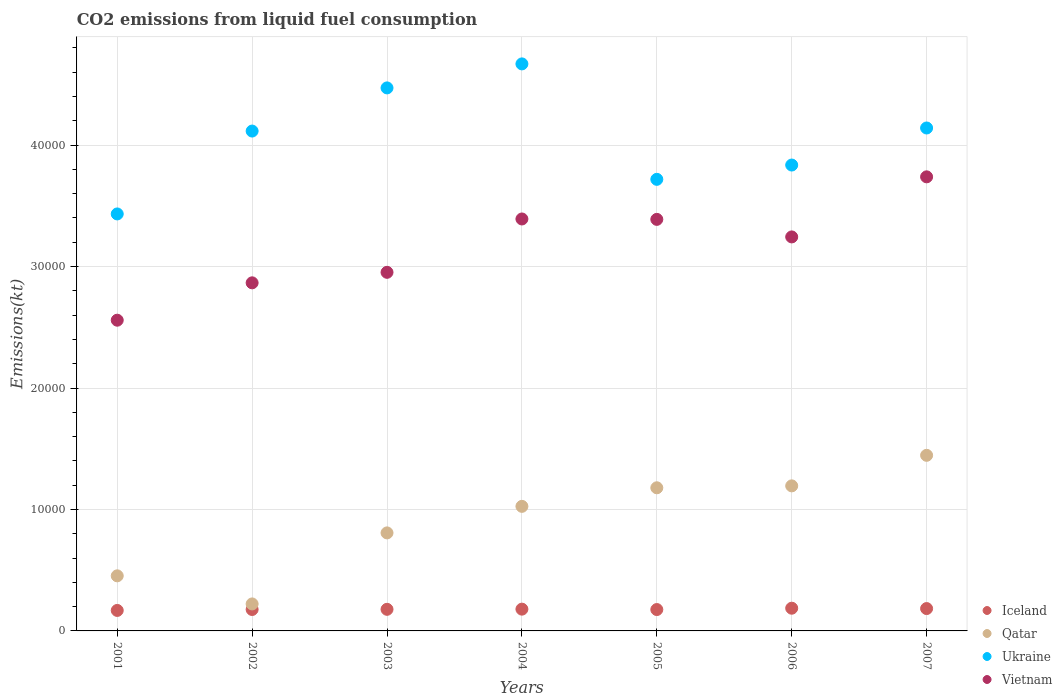How many different coloured dotlines are there?
Your response must be concise. 4. Is the number of dotlines equal to the number of legend labels?
Your answer should be compact. Yes. What is the amount of CO2 emitted in Vietnam in 2003?
Make the answer very short. 2.95e+04. Across all years, what is the maximum amount of CO2 emitted in Vietnam?
Give a very brief answer. 3.74e+04. Across all years, what is the minimum amount of CO2 emitted in Qatar?
Keep it short and to the point. 2222.2. In which year was the amount of CO2 emitted in Qatar maximum?
Your answer should be compact. 2007. What is the total amount of CO2 emitted in Qatar in the graph?
Provide a short and direct response. 6.33e+04. What is the difference between the amount of CO2 emitted in Ukraine in 2001 and that in 2002?
Make the answer very short. -6824.29. What is the difference between the amount of CO2 emitted in Vietnam in 2003 and the amount of CO2 emitted in Qatar in 2001?
Offer a terse response. 2.50e+04. What is the average amount of CO2 emitted in Ukraine per year?
Offer a terse response. 4.05e+04. In the year 2004, what is the difference between the amount of CO2 emitted in Ukraine and amount of CO2 emitted in Vietnam?
Offer a terse response. 1.28e+04. In how many years, is the amount of CO2 emitted in Vietnam greater than 46000 kt?
Your response must be concise. 0. What is the ratio of the amount of CO2 emitted in Ukraine in 2003 to that in 2005?
Make the answer very short. 1.2. Is the amount of CO2 emitted in Iceland in 2003 less than that in 2005?
Keep it short and to the point. No. What is the difference between the highest and the second highest amount of CO2 emitted in Ukraine?
Give a very brief answer. 1976.51. What is the difference between the highest and the lowest amount of CO2 emitted in Qatar?
Offer a terse response. 1.22e+04. Is it the case that in every year, the sum of the amount of CO2 emitted in Ukraine and amount of CO2 emitted in Iceland  is greater than the amount of CO2 emitted in Vietnam?
Keep it short and to the point. Yes. Is the amount of CO2 emitted in Vietnam strictly greater than the amount of CO2 emitted in Qatar over the years?
Your response must be concise. Yes. Are the values on the major ticks of Y-axis written in scientific E-notation?
Give a very brief answer. No. Does the graph contain any zero values?
Keep it short and to the point. No. Where does the legend appear in the graph?
Your response must be concise. Bottom right. What is the title of the graph?
Make the answer very short. CO2 emissions from liquid fuel consumption. Does "Mozambique" appear as one of the legend labels in the graph?
Offer a terse response. No. What is the label or title of the Y-axis?
Your answer should be very brief. Emissions(kt). What is the Emissions(kt) in Iceland in 2001?
Give a very brief answer. 1686.82. What is the Emissions(kt) in Qatar in 2001?
Offer a terse response. 4536.08. What is the Emissions(kt) of Ukraine in 2001?
Your answer should be compact. 3.43e+04. What is the Emissions(kt) of Vietnam in 2001?
Provide a short and direct response. 2.56e+04. What is the Emissions(kt) in Iceland in 2002?
Ensure brevity in your answer.  1763.83. What is the Emissions(kt) in Qatar in 2002?
Your answer should be compact. 2222.2. What is the Emissions(kt) in Ukraine in 2002?
Keep it short and to the point. 4.12e+04. What is the Emissions(kt) of Vietnam in 2002?
Offer a terse response. 2.87e+04. What is the Emissions(kt) of Iceland in 2003?
Your answer should be very brief. 1778.49. What is the Emissions(kt) in Qatar in 2003?
Your response must be concise. 8071.07. What is the Emissions(kt) of Ukraine in 2003?
Your response must be concise. 4.47e+04. What is the Emissions(kt) of Vietnam in 2003?
Ensure brevity in your answer.  2.95e+04. What is the Emissions(kt) of Iceland in 2004?
Your answer should be compact. 1793.16. What is the Emissions(kt) in Qatar in 2004?
Keep it short and to the point. 1.03e+04. What is the Emissions(kt) in Ukraine in 2004?
Provide a short and direct response. 4.67e+04. What is the Emissions(kt) of Vietnam in 2004?
Make the answer very short. 3.39e+04. What is the Emissions(kt) in Iceland in 2005?
Ensure brevity in your answer.  1760.16. What is the Emissions(kt) of Qatar in 2005?
Provide a short and direct response. 1.18e+04. What is the Emissions(kt) in Ukraine in 2005?
Give a very brief answer. 3.72e+04. What is the Emissions(kt) in Vietnam in 2005?
Give a very brief answer. 3.39e+04. What is the Emissions(kt) of Iceland in 2006?
Your answer should be very brief. 1870.17. What is the Emissions(kt) of Qatar in 2006?
Offer a very short reply. 1.19e+04. What is the Emissions(kt) of Ukraine in 2006?
Provide a short and direct response. 3.84e+04. What is the Emissions(kt) in Vietnam in 2006?
Provide a succinct answer. 3.24e+04. What is the Emissions(kt) of Iceland in 2007?
Keep it short and to the point. 1840.83. What is the Emissions(kt) in Qatar in 2007?
Keep it short and to the point. 1.45e+04. What is the Emissions(kt) in Ukraine in 2007?
Offer a very short reply. 4.14e+04. What is the Emissions(kt) in Vietnam in 2007?
Make the answer very short. 3.74e+04. Across all years, what is the maximum Emissions(kt) of Iceland?
Ensure brevity in your answer.  1870.17. Across all years, what is the maximum Emissions(kt) of Qatar?
Provide a succinct answer. 1.45e+04. Across all years, what is the maximum Emissions(kt) of Ukraine?
Offer a very short reply. 4.67e+04. Across all years, what is the maximum Emissions(kt) in Vietnam?
Your response must be concise. 3.74e+04. Across all years, what is the minimum Emissions(kt) in Iceland?
Keep it short and to the point. 1686.82. Across all years, what is the minimum Emissions(kt) in Qatar?
Your response must be concise. 2222.2. Across all years, what is the minimum Emissions(kt) in Ukraine?
Your response must be concise. 3.43e+04. Across all years, what is the minimum Emissions(kt) of Vietnam?
Provide a short and direct response. 2.56e+04. What is the total Emissions(kt) of Iceland in the graph?
Your answer should be compact. 1.25e+04. What is the total Emissions(kt) in Qatar in the graph?
Keep it short and to the point. 6.33e+04. What is the total Emissions(kt) of Ukraine in the graph?
Your answer should be very brief. 2.84e+05. What is the total Emissions(kt) of Vietnam in the graph?
Offer a terse response. 2.21e+05. What is the difference between the Emissions(kt) in Iceland in 2001 and that in 2002?
Provide a succinct answer. -77.01. What is the difference between the Emissions(kt) of Qatar in 2001 and that in 2002?
Keep it short and to the point. 2313.88. What is the difference between the Emissions(kt) of Ukraine in 2001 and that in 2002?
Offer a terse response. -6824.29. What is the difference between the Emissions(kt) in Vietnam in 2001 and that in 2002?
Your response must be concise. -3076.61. What is the difference between the Emissions(kt) in Iceland in 2001 and that in 2003?
Ensure brevity in your answer.  -91.67. What is the difference between the Emissions(kt) in Qatar in 2001 and that in 2003?
Offer a terse response. -3534.99. What is the difference between the Emissions(kt) of Ukraine in 2001 and that in 2003?
Offer a terse response. -1.04e+04. What is the difference between the Emissions(kt) of Vietnam in 2001 and that in 2003?
Keep it short and to the point. -3942.03. What is the difference between the Emissions(kt) in Iceland in 2001 and that in 2004?
Offer a terse response. -106.34. What is the difference between the Emissions(kt) in Qatar in 2001 and that in 2004?
Give a very brief answer. -5720.52. What is the difference between the Emissions(kt) in Ukraine in 2001 and that in 2004?
Provide a short and direct response. -1.24e+04. What is the difference between the Emissions(kt) of Vietnam in 2001 and that in 2004?
Keep it short and to the point. -8335.09. What is the difference between the Emissions(kt) of Iceland in 2001 and that in 2005?
Offer a terse response. -73.34. What is the difference between the Emissions(kt) in Qatar in 2001 and that in 2005?
Ensure brevity in your answer.  -7249.66. What is the difference between the Emissions(kt) in Ukraine in 2001 and that in 2005?
Your answer should be compact. -2849.26. What is the difference between the Emissions(kt) of Vietnam in 2001 and that in 2005?
Keep it short and to the point. -8302.09. What is the difference between the Emissions(kt) in Iceland in 2001 and that in 2006?
Keep it short and to the point. -183.35. What is the difference between the Emissions(kt) of Qatar in 2001 and that in 2006?
Your answer should be very brief. -7407.34. What is the difference between the Emissions(kt) in Ukraine in 2001 and that in 2006?
Keep it short and to the point. -4026.37. What is the difference between the Emissions(kt) of Vietnam in 2001 and that in 2006?
Ensure brevity in your answer.  -6857.29. What is the difference between the Emissions(kt) of Iceland in 2001 and that in 2007?
Provide a short and direct response. -154.01. What is the difference between the Emissions(kt) of Qatar in 2001 and that in 2007?
Give a very brief answer. -9922.9. What is the difference between the Emissions(kt) in Ukraine in 2001 and that in 2007?
Your response must be concise. -7077.31. What is the difference between the Emissions(kt) in Vietnam in 2001 and that in 2007?
Provide a succinct answer. -1.18e+04. What is the difference between the Emissions(kt) of Iceland in 2002 and that in 2003?
Provide a short and direct response. -14.67. What is the difference between the Emissions(kt) in Qatar in 2002 and that in 2003?
Offer a terse response. -5848.86. What is the difference between the Emissions(kt) of Ukraine in 2002 and that in 2003?
Provide a succinct answer. -3553.32. What is the difference between the Emissions(kt) in Vietnam in 2002 and that in 2003?
Your answer should be compact. -865.41. What is the difference between the Emissions(kt) in Iceland in 2002 and that in 2004?
Your answer should be very brief. -29.34. What is the difference between the Emissions(kt) of Qatar in 2002 and that in 2004?
Make the answer very short. -8034.4. What is the difference between the Emissions(kt) in Ukraine in 2002 and that in 2004?
Your response must be concise. -5529.84. What is the difference between the Emissions(kt) of Vietnam in 2002 and that in 2004?
Provide a short and direct response. -5258.48. What is the difference between the Emissions(kt) of Iceland in 2002 and that in 2005?
Your response must be concise. 3.67. What is the difference between the Emissions(kt) of Qatar in 2002 and that in 2005?
Provide a short and direct response. -9563.54. What is the difference between the Emissions(kt) of Ukraine in 2002 and that in 2005?
Your answer should be compact. 3975.03. What is the difference between the Emissions(kt) in Vietnam in 2002 and that in 2005?
Your answer should be very brief. -5225.48. What is the difference between the Emissions(kt) in Iceland in 2002 and that in 2006?
Your answer should be compact. -106.34. What is the difference between the Emissions(kt) in Qatar in 2002 and that in 2006?
Provide a short and direct response. -9721.22. What is the difference between the Emissions(kt) in Ukraine in 2002 and that in 2006?
Offer a very short reply. 2797.92. What is the difference between the Emissions(kt) of Vietnam in 2002 and that in 2006?
Give a very brief answer. -3780.68. What is the difference between the Emissions(kt) of Iceland in 2002 and that in 2007?
Give a very brief answer. -77.01. What is the difference between the Emissions(kt) in Qatar in 2002 and that in 2007?
Ensure brevity in your answer.  -1.22e+04. What is the difference between the Emissions(kt) in Ukraine in 2002 and that in 2007?
Your answer should be very brief. -253.02. What is the difference between the Emissions(kt) of Vietnam in 2002 and that in 2007?
Keep it short and to the point. -8727.46. What is the difference between the Emissions(kt) in Iceland in 2003 and that in 2004?
Provide a succinct answer. -14.67. What is the difference between the Emissions(kt) of Qatar in 2003 and that in 2004?
Provide a short and direct response. -2185.53. What is the difference between the Emissions(kt) of Ukraine in 2003 and that in 2004?
Offer a terse response. -1976.51. What is the difference between the Emissions(kt) of Vietnam in 2003 and that in 2004?
Ensure brevity in your answer.  -4393.07. What is the difference between the Emissions(kt) of Iceland in 2003 and that in 2005?
Give a very brief answer. 18.34. What is the difference between the Emissions(kt) of Qatar in 2003 and that in 2005?
Ensure brevity in your answer.  -3714.67. What is the difference between the Emissions(kt) of Ukraine in 2003 and that in 2005?
Your answer should be very brief. 7528.35. What is the difference between the Emissions(kt) in Vietnam in 2003 and that in 2005?
Offer a terse response. -4360.06. What is the difference between the Emissions(kt) of Iceland in 2003 and that in 2006?
Offer a terse response. -91.67. What is the difference between the Emissions(kt) in Qatar in 2003 and that in 2006?
Keep it short and to the point. -3872.35. What is the difference between the Emissions(kt) of Ukraine in 2003 and that in 2006?
Offer a very short reply. 6351.24. What is the difference between the Emissions(kt) of Vietnam in 2003 and that in 2006?
Provide a short and direct response. -2915.26. What is the difference between the Emissions(kt) in Iceland in 2003 and that in 2007?
Your answer should be compact. -62.34. What is the difference between the Emissions(kt) in Qatar in 2003 and that in 2007?
Your response must be concise. -6387.91. What is the difference between the Emissions(kt) of Ukraine in 2003 and that in 2007?
Give a very brief answer. 3300.3. What is the difference between the Emissions(kt) in Vietnam in 2003 and that in 2007?
Offer a very short reply. -7862.05. What is the difference between the Emissions(kt) of Iceland in 2004 and that in 2005?
Ensure brevity in your answer.  33. What is the difference between the Emissions(kt) in Qatar in 2004 and that in 2005?
Your answer should be compact. -1529.14. What is the difference between the Emissions(kt) of Ukraine in 2004 and that in 2005?
Give a very brief answer. 9504.86. What is the difference between the Emissions(kt) in Vietnam in 2004 and that in 2005?
Offer a very short reply. 33. What is the difference between the Emissions(kt) of Iceland in 2004 and that in 2006?
Your answer should be very brief. -77.01. What is the difference between the Emissions(kt) in Qatar in 2004 and that in 2006?
Make the answer very short. -1686.82. What is the difference between the Emissions(kt) in Ukraine in 2004 and that in 2006?
Ensure brevity in your answer.  8327.76. What is the difference between the Emissions(kt) in Vietnam in 2004 and that in 2006?
Ensure brevity in your answer.  1477.8. What is the difference between the Emissions(kt) of Iceland in 2004 and that in 2007?
Make the answer very short. -47.67. What is the difference between the Emissions(kt) in Qatar in 2004 and that in 2007?
Keep it short and to the point. -4202.38. What is the difference between the Emissions(kt) in Ukraine in 2004 and that in 2007?
Provide a short and direct response. 5276.81. What is the difference between the Emissions(kt) of Vietnam in 2004 and that in 2007?
Make the answer very short. -3468.98. What is the difference between the Emissions(kt) of Iceland in 2005 and that in 2006?
Your response must be concise. -110.01. What is the difference between the Emissions(kt) in Qatar in 2005 and that in 2006?
Ensure brevity in your answer.  -157.68. What is the difference between the Emissions(kt) in Ukraine in 2005 and that in 2006?
Make the answer very short. -1177.11. What is the difference between the Emissions(kt) in Vietnam in 2005 and that in 2006?
Ensure brevity in your answer.  1444.8. What is the difference between the Emissions(kt) of Iceland in 2005 and that in 2007?
Make the answer very short. -80.67. What is the difference between the Emissions(kt) of Qatar in 2005 and that in 2007?
Ensure brevity in your answer.  -2673.24. What is the difference between the Emissions(kt) of Ukraine in 2005 and that in 2007?
Provide a succinct answer. -4228.05. What is the difference between the Emissions(kt) in Vietnam in 2005 and that in 2007?
Keep it short and to the point. -3501.99. What is the difference between the Emissions(kt) in Iceland in 2006 and that in 2007?
Offer a terse response. 29.34. What is the difference between the Emissions(kt) in Qatar in 2006 and that in 2007?
Give a very brief answer. -2515.56. What is the difference between the Emissions(kt) in Ukraine in 2006 and that in 2007?
Your response must be concise. -3050.94. What is the difference between the Emissions(kt) in Vietnam in 2006 and that in 2007?
Keep it short and to the point. -4946.78. What is the difference between the Emissions(kt) of Iceland in 2001 and the Emissions(kt) of Qatar in 2002?
Give a very brief answer. -535.38. What is the difference between the Emissions(kt) in Iceland in 2001 and the Emissions(kt) in Ukraine in 2002?
Keep it short and to the point. -3.95e+04. What is the difference between the Emissions(kt) of Iceland in 2001 and the Emissions(kt) of Vietnam in 2002?
Provide a short and direct response. -2.70e+04. What is the difference between the Emissions(kt) of Qatar in 2001 and the Emissions(kt) of Ukraine in 2002?
Provide a short and direct response. -3.66e+04. What is the difference between the Emissions(kt) of Qatar in 2001 and the Emissions(kt) of Vietnam in 2002?
Give a very brief answer. -2.41e+04. What is the difference between the Emissions(kt) in Ukraine in 2001 and the Emissions(kt) in Vietnam in 2002?
Your response must be concise. 5672.85. What is the difference between the Emissions(kt) of Iceland in 2001 and the Emissions(kt) of Qatar in 2003?
Your answer should be very brief. -6384.25. What is the difference between the Emissions(kt) of Iceland in 2001 and the Emissions(kt) of Ukraine in 2003?
Offer a very short reply. -4.30e+04. What is the difference between the Emissions(kt) of Iceland in 2001 and the Emissions(kt) of Vietnam in 2003?
Make the answer very short. -2.78e+04. What is the difference between the Emissions(kt) in Qatar in 2001 and the Emissions(kt) in Ukraine in 2003?
Offer a very short reply. -4.02e+04. What is the difference between the Emissions(kt) in Qatar in 2001 and the Emissions(kt) in Vietnam in 2003?
Make the answer very short. -2.50e+04. What is the difference between the Emissions(kt) of Ukraine in 2001 and the Emissions(kt) of Vietnam in 2003?
Keep it short and to the point. 4807.44. What is the difference between the Emissions(kt) in Iceland in 2001 and the Emissions(kt) in Qatar in 2004?
Your answer should be very brief. -8569.78. What is the difference between the Emissions(kt) of Iceland in 2001 and the Emissions(kt) of Ukraine in 2004?
Offer a terse response. -4.50e+04. What is the difference between the Emissions(kt) of Iceland in 2001 and the Emissions(kt) of Vietnam in 2004?
Your answer should be compact. -3.22e+04. What is the difference between the Emissions(kt) of Qatar in 2001 and the Emissions(kt) of Ukraine in 2004?
Your answer should be very brief. -4.22e+04. What is the difference between the Emissions(kt) of Qatar in 2001 and the Emissions(kt) of Vietnam in 2004?
Offer a terse response. -2.94e+04. What is the difference between the Emissions(kt) in Ukraine in 2001 and the Emissions(kt) in Vietnam in 2004?
Offer a terse response. 414.37. What is the difference between the Emissions(kt) in Iceland in 2001 and the Emissions(kt) in Qatar in 2005?
Your answer should be very brief. -1.01e+04. What is the difference between the Emissions(kt) of Iceland in 2001 and the Emissions(kt) of Ukraine in 2005?
Offer a very short reply. -3.55e+04. What is the difference between the Emissions(kt) in Iceland in 2001 and the Emissions(kt) in Vietnam in 2005?
Give a very brief answer. -3.22e+04. What is the difference between the Emissions(kt) in Qatar in 2001 and the Emissions(kt) in Ukraine in 2005?
Give a very brief answer. -3.26e+04. What is the difference between the Emissions(kt) in Qatar in 2001 and the Emissions(kt) in Vietnam in 2005?
Provide a succinct answer. -2.94e+04. What is the difference between the Emissions(kt) in Ukraine in 2001 and the Emissions(kt) in Vietnam in 2005?
Ensure brevity in your answer.  447.37. What is the difference between the Emissions(kt) of Iceland in 2001 and the Emissions(kt) of Qatar in 2006?
Make the answer very short. -1.03e+04. What is the difference between the Emissions(kt) of Iceland in 2001 and the Emissions(kt) of Ukraine in 2006?
Make the answer very short. -3.67e+04. What is the difference between the Emissions(kt) in Iceland in 2001 and the Emissions(kt) in Vietnam in 2006?
Your response must be concise. -3.08e+04. What is the difference between the Emissions(kt) in Qatar in 2001 and the Emissions(kt) in Ukraine in 2006?
Give a very brief answer. -3.38e+04. What is the difference between the Emissions(kt) of Qatar in 2001 and the Emissions(kt) of Vietnam in 2006?
Your response must be concise. -2.79e+04. What is the difference between the Emissions(kt) of Ukraine in 2001 and the Emissions(kt) of Vietnam in 2006?
Make the answer very short. 1892.17. What is the difference between the Emissions(kt) of Iceland in 2001 and the Emissions(kt) of Qatar in 2007?
Offer a terse response. -1.28e+04. What is the difference between the Emissions(kt) of Iceland in 2001 and the Emissions(kt) of Ukraine in 2007?
Keep it short and to the point. -3.97e+04. What is the difference between the Emissions(kt) in Iceland in 2001 and the Emissions(kt) in Vietnam in 2007?
Provide a succinct answer. -3.57e+04. What is the difference between the Emissions(kt) of Qatar in 2001 and the Emissions(kt) of Ukraine in 2007?
Your answer should be compact. -3.69e+04. What is the difference between the Emissions(kt) of Qatar in 2001 and the Emissions(kt) of Vietnam in 2007?
Offer a terse response. -3.29e+04. What is the difference between the Emissions(kt) in Ukraine in 2001 and the Emissions(kt) in Vietnam in 2007?
Offer a terse response. -3054.61. What is the difference between the Emissions(kt) of Iceland in 2002 and the Emissions(kt) of Qatar in 2003?
Make the answer very short. -6307.24. What is the difference between the Emissions(kt) of Iceland in 2002 and the Emissions(kt) of Ukraine in 2003?
Provide a short and direct response. -4.29e+04. What is the difference between the Emissions(kt) of Iceland in 2002 and the Emissions(kt) of Vietnam in 2003?
Offer a terse response. -2.78e+04. What is the difference between the Emissions(kt) in Qatar in 2002 and the Emissions(kt) in Ukraine in 2003?
Your response must be concise. -4.25e+04. What is the difference between the Emissions(kt) in Qatar in 2002 and the Emissions(kt) in Vietnam in 2003?
Provide a succinct answer. -2.73e+04. What is the difference between the Emissions(kt) of Ukraine in 2002 and the Emissions(kt) of Vietnam in 2003?
Provide a short and direct response. 1.16e+04. What is the difference between the Emissions(kt) of Iceland in 2002 and the Emissions(kt) of Qatar in 2004?
Ensure brevity in your answer.  -8492.77. What is the difference between the Emissions(kt) in Iceland in 2002 and the Emissions(kt) in Ukraine in 2004?
Your answer should be very brief. -4.49e+04. What is the difference between the Emissions(kt) of Iceland in 2002 and the Emissions(kt) of Vietnam in 2004?
Your answer should be compact. -3.22e+04. What is the difference between the Emissions(kt) in Qatar in 2002 and the Emissions(kt) in Ukraine in 2004?
Make the answer very short. -4.45e+04. What is the difference between the Emissions(kt) of Qatar in 2002 and the Emissions(kt) of Vietnam in 2004?
Keep it short and to the point. -3.17e+04. What is the difference between the Emissions(kt) of Ukraine in 2002 and the Emissions(kt) of Vietnam in 2004?
Offer a very short reply. 7238.66. What is the difference between the Emissions(kt) in Iceland in 2002 and the Emissions(kt) in Qatar in 2005?
Ensure brevity in your answer.  -1.00e+04. What is the difference between the Emissions(kt) of Iceland in 2002 and the Emissions(kt) of Ukraine in 2005?
Keep it short and to the point. -3.54e+04. What is the difference between the Emissions(kt) in Iceland in 2002 and the Emissions(kt) in Vietnam in 2005?
Give a very brief answer. -3.21e+04. What is the difference between the Emissions(kt) of Qatar in 2002 and the Emissions(kt) of Ukraine in 2005?
Your answer should be very brief. -3.50e+04. What is the difference between the Emissions(kt) in Qatar in 2002 and the Emissions(kt) in Vietnam in 2005?
Your answer should be compact. -3.17e+04. What is the difference between the Emissions(kt) in Ukraine in 2002 and the Emissions(kt) in Vietnam in 2005?
Keep it short and to the point. 7271.66. What is the difference between the Emissions(kt) in Iceland in 2002 and the Emissions(kt) in Qatar in 2006?
Offer a very short reply. -1.02e+04. What is the difference between the Emissions(kt) of Iceland in 2002 and the Emissions(kt) of Ukraine in 2006?
Your answer should be very brief. -3.66e+04. What is the difference between the Emissions(kt) in Iceland in 2002 and the Emissions(kt) in Vietnam in 2006?
Your response must be concise. -3.07e+04. What is the difference between the Emissions(kt) in Qatar in 2002 and the Emissions(kt) in Ukraine in 2006?
Offer a very short reply. -3.61e+04. What is the difference between the Emissions(kt) in Qatar in 2002 and the Emissions(kt) in Vietnam in 2006?
Offer a very short reply. -3.02e+04. What is the difference between the Emissions(kt) of Ukraine in 2002 and the Emissions(kt) of Vietnam in 2006?
Keep it short and to the point. 8716.46. What is the difference between the Emissions(kt) in Iceland in 2002 and the Emissions(kt) in Qatar in 2007?
Your response must be concise. -1.27e+04. What is the difference between the Emissions(kt) of Iceland in 2002 and the Emissions(kt) of Ukraine in 2007?
Give a very brief answer. -3.96e+04. What is the difference between the Emissions(kt) of Iceland in 2002 and the Emissions(kt) of Vietnam in 2007?
Make the answer very short. -3.56e+04. What is the difference between the Emissions(kt) in Qatar in 2002 and the Emissions(kt) in Ukraine in 2007?
Offer a very short reply. -3.92e+04. What is the difference between the Emissions(kt) in Qatar in 2002 and the Emissions(kt) in Vietnam in 2007?
Provide a succinct answer. -3.52e+04. What is the difference between the Emissions(kt) in Ukraine in 2002 and the Emissions(kt) in Vietnam in 2007?
Your response must be concise. 3769.68. What is the difference between the Emissions(kt) in Iceland in 2003 and the Emissions(kt) in Qatar in 2004?
Provide a succinct answer. -8478.1. What is the difference between the Emissions(kt) of Iceland in 2003 and the Emissions(kt) of Ukraine in 2004?
Offer a very short reply. -4.49e+04. What is the difference between the Emissions(kt) of Iceland in 2003 and the Emissions(kt) of Vietnam in 2004?
Give a very brief answer. -3.21e+04. What is the difference between the Emissions(kt) in Qatar in 2003 and the Emissions(kt) in Ukraine in 2004?
Offer a very short reply. -3.86e+04. What is the difference between the Emissions(kt) in Qatar in 2003 and the Emissions(kt) in Vietnam in 2004?
Your answer should be very brief. -2.58e+04. What is the difference between the Emissions(kt) in Ukraine in 2003 and the Emissions(kt) in Vietnam in 2004?
Provide a succinct answer. 1.08e+04. What is the difference between the Emissions(kt) in Iceland in 2003 and the Emissions(kt) in Qatar in 2005?
Provide a short and direct response. -1.00e+04. What is the difference between the Emissions(kt) in Iceland in 2003 and the Emissions(kt) in Ukraine in 2005?
Give a very brief answer. -3.54e+04. What is the difference between the Emissions(kt) in Iceland in 2003 and the Emissions(kt) in Vietnam in 2005?
Your answer should be compact. -3.21e+04. What is the difference between the Emissions(kt) of Qatar in 2003 and the Emissions(kt) of Ukraine in 2005?
Your answer should be very brief. -2.91e+04. What is the difference between the Emissions(kt) in Qatar in 2003 and the Emissions(kt) in Vietnam in 2005?
Ensure brevity in your answer.  -2.58e+04. What is the difference between the Emissions(kt) in Ukraine in 2003 and the Emissions(kt) in Vietnam in 2005?
Provide a short and direct response. 1.08e+04. What is the difference between the Emissions(kt) of Iceland in 2003 and the Emissions(kt) of Qatar in 2006?
Offer a terse response. -1.02e+04. What is the difference between the Emissions(kt) of Iceland in 2003 and the Emissions(kt) of Ukraine in 2006?
Make the answer very short. -3.66e+04. What is the difference between the Emissions(kt) in Iceland in 2003 and the Emissions(kt) in Vietnam in 2006?
Offer a very short reply. -3.07e+04. What is the difference between the Emissions(kt) of Qatar in 2003 and the Emissions(kt) of Ukraine in 2006?
Offer a terse response. -3.03e+04. What is the difference between the Emissions(kt) in Qatar in 2003 and the Emissions(kt) in Vietnam in 2006?
Provide a short and direct response. -2.44e+04. What is the difference between the Emissions(kt) in Ukraine in 2003 and the Emissions(kt) in Vietnam in 2006?
Keep it short and to the point. 1.23e+04. What is the difference between the Emissions(kt) of Iceland in 2003 and the Emissions(kt) of Qatar in 2007?
Provide a succinct answer. -1.27e+04. What is the difference between the Emissions(kt) of Iceland in 2003 and the Emissions(kt) of Ukraine in 2007?
Your answer should be very brief. -3.96e+04. What is the difference between the Emissions(kt) in Iceland in 2003 and the Emissions(kt) in Vietnam in 2007?
Give a very brief answer. -3.56e+04. What is the difference between the Emissions(kt) in Qatar in 2003 and the Emissions(kt) in Ukraine in 2007?
Your answer should be very brief. -3.33e+04. What is the difference between the Emissions(kt) in Qatar in 2003 and the Emissions(kt) in Vietnam in 2007?
Make the answer very short. -2.93e+04. What is the difference between the Emissions(kt) of Ukraine in 2003 and the Emissions(kt) of Vietnam in 2007?
Offer a very short reply. 7323. What is the difference between the Emissions(kt) of Iceland in 2004 and the Emissions(kt) of Qatar in 2005?
Give a very brief answer. -9992.58. What is the difference between the Emissions(kt) of Iceland in 2004 and the Emissions(kt) of Ukraine in 2005?
Provide a short and direct response. -3.54e+04. What is the difference between the Emissions(kt) of Iceland in 2004 and the Emissions(kt) of Vietnam in 2005?
Your answer should be very brief. -3.21e+04. What is the difference between the Emissions(kt) of Qatar in 2004 and the Emissions(kt) of Ukraine in 2005?
Your answer should be compact. -2.69e+04. What is the difference between the Emissions(kt) in Qatar in 2004 and the Emissions(kt) in Vietnam in 2005?
Offer a very short reply. -2.36e+04. What is the difference between the Emissions(kt) of Ukraine in 2004 and the Emissions(kt) of Vietnam in 2005?
Provide a succinct answer. 1.28e+04. What is the difference between the Emissions(kt) in Iceland in 2004 and the Emissions(kt) in Qatar in 2006?
Offer a very short reply. -1.02e+04. What is the difference between the Emissions(kt) in Iceland in 2004 and the Emissions(kt) in Ukraine in 2006?
Provide a succinct answer. -3.66e+04. What is the difference between the Emissions(kt) in Iceland in 2004 and the Emissions(kt) in Vietnam in 2006?
Keep it short and to the point. -3.06e+04. What is the difference between the Emissions(kt) in Qatar in 2004 and the Emissions(kt) in Ukraine in 2006?
Your answer should be compact. -2.81e+04. What is the difference between the Emissions(kt) of Qatar in 2004 and the Emissions(kt) of Vietnam in 2006?
Your answer should be very brief. -2.22e+04. What is the difference between the Emissions(kt) in Ukraine in 2004 and the Emissions(kt) in Vietnam in 2006?
Your answer should be very brief. 1.42e+04. What is the difference between the Emissions(kt) in Iceland in 2004 and the Emissions(kt) in Qatar in 2007?
Offer a very short reply. -1.27e+04. What is the difference between the Emissions(kt) of Iceland in 2004 and the Emissions(kt) of Ukraine in 2007?
Your answer should be very brief. -3.96e+04. What is the difference between the Emissions(kt) of Iceland in 2004 and the Emissions(kt) of Vietnam in 2007?
Provide a succinct answer. -3.56e+04. What is the difference between the Emissions(kt) of Qatar in 2004 and the Emissions(kt) of Ukraine in 2007?
Keep it short and to the point. -3.12e+04. What is the difference between the Emissions(kt) in Qatar in 2004 and the Emissions(kt) in Vietnam in 2007?
Your answer should be compact. -2.71e+04. What is the difference between the Emissions(kt) of Ukraine in 2004 and the Emissions(kt) of Vietnam in 2007?
Ensure brevity in your answer.  9299.51. What is the difference between the Emissions(kt) in Iceland in 2005 and the Emissions(kt) in Qatar in 2006?
Your response must be concise. -1.02e+04. What is the difference between the Emissions(kt) of Iceland in 2005 and the Emissions(kt) of Ukraine in 2006?
Provide a succinct answer. -3.66e+04. What is the difference between the Emissions(kt) of Iceland in 2005 and the Emissions(kt) of Vietnam in 2006?
Make the answer very short. -3.07e+04. What is the difference between the Emissions(kt) of Qatar in 2005 and the Emissions(kt) of Ukraine in 2006?
Your answer should be very brief. -2.66e+04. What is the difference between the Emissions(kt) of Qatar in 2005 and the Emissions(kt) of Vietnam in 2006?
Give a very brief answer. -2.07e+04. What is the difference between the Emissions(kt) in Ukraine in 2005 and the Emissions(kt) in Vietnam in 2006?
Provide a succinct answer. 4741.43. What is the difference between the Emissions(kt) in Iceland in 2005 and the Emissions(kt) in Qatar in 2007?
Ensure brevity in your answer.  -1.27e+04. What is the difference between the Emissions(kt) of Iceland in 2005 and the Emissions(kt) of Ukraine in 2007?
Offer a very short reply. -3.97e+04. What is the difference between the Emissions(kt) of Iceland in 2005 and the Emissions(kt) of Vietnam in 2007?
Offer a very short reply. -3.56e+04. What is the difference between the Emissions(kt) in Qatar in 2005 and the Emissions(kt) in Ukraine in 2007?
Your response must be concise. -2.96e+04. What is the difference between the Emissions(kt) of Qatar in 2005 and the Emissions(kt) of Vietnam in 2007?
Offer a terse response. -2.56e+04. What is the difference between the Emissions(kt) of Ukraine in 2005 and the Emissions(kt) of Vietnam in 2007?
Give a very brief answer. -205.35. What is the difference between the Emissions(kt) in Iceland in 2006 and the Emissions(kt) in Qatar in 2007?
Your response must be concise. -1.26e+04. What is the difference between the Emissions(kt) in Iceland in 2006 and the Emissions(kt) in Ukraine in 2007?
Offer a very short reply. -3.95e+04. What is the difference between the Emissions(kt) in Iceland in 2006 and the Emissions(kt) in Vietnam in 2007?
Provide a succinct answer. -3.55e+04. What is the difference between the Emissions(kt) in Qatar in 2006 and the Emissions(kt) in Ukraine in 2007?
Offer a terse response. -2.95e+04. What is the difference between the Emissions(kt) in Qatar in 2006 and the Emissions(kt) in Vietnam in 2007?
Provide a succinct answer. -2.54e+04. What is the difference between the Emissions(kt) in Ukraine in 2006 and the Emissions(kt) in Vietnam in 2007?
Provide a succinct answer. 971.75. What is the average Emissions(kt) of Iceland per year?
Ensure brevity in your answer.  1784.78. What is the average Emissions(kt) in Qatar per year?
Provide a succinct answer. 9039.16. What is the average Emissions(kt) in Ukraine per year?
Provide a succinct answer. 4.05e+04. What is the average Emissions(kt) of Vietnam per year?
Offer a very short reply. 3.16e+04. In the year 2001, what is the difference between the Emissions(kt) of Iceland and Emissions(kt) of Qatar?
Provide a succinct answer. -2849.26. In the year 2001, what is the difference between the Emissions(kt) of Iceland and Emissions(kt) of Ukraine?
Provide a succinct answer. -3.26e+04. In the year 2001, what is the difference between the Emissions(kt) in Iceland and Emissions(kt) in Vietnam?
Your answer should be compact. -2.39e+04. In the year 2001, what is the difference between the Emissions(kt) in Qatar and Emissions(kt) in Ukraine?
Provide a succinct answer. -2.98e+04. In the year 2001, what is the difference between the Emissions(kt) of Qatar and Emissions(kt) of Vietnam?
Give a very brief answer. -2.10e+04. In the year 2001, what is the difference between the Emissions(kt) of Ukraine and Emissions(kt) of Vietnam?
Ensure brevity in your answer.  8749.46. In the year 2002, what is the difference between the Emissions(kt) in Iceland and Emissions(kt) in Qatar?
Keep it short and to the point. -458.38. In the year 2002, what is the difference between the Emissions(kt) in Iceland and Emissions(kt) in Ukraine?
Provide a succinct answer. -3.94e+04. In the year 2002, what is the difference between the Emissions(kt) of Iceland and Emissions(kt) of Vietnam?
Ensure brevity in your answer.  -2.69e+04. In the year 2002, what is the difference between the Emissions(kt) of Qatar and Emissions(kt) of Ukraine?
Provide a succinct answer. -3.89e+04. In the year 2002, what is the difference between the Emissions(kt) of Qatar and Emissions(kt) of Vietnam?
Offer a terse response. -2.64e+04. In the year 2002, what is the difference between the Emissions(kt) of Ukraine and Emissions(kt) of Vietnam?
Your answer should be compact. 1.25e+04. In the year 2003, what is the difference between the Emissions(kt) in Iceland and Emissions(kt) in Qatar?
Ensure brevity in your answer.  -6292.57. In the year 2003, what is the difference between the Emissions(kt) of Iceland and Emissions(kt) of Ukraine?
Make the answer very short. -4.29e+04. In the year 2003, what is the difference between the Emissions(kt) of Iceland and Emissions(kt) of Vietnam?
Ensure brevity in your answer.  -2.77e+04. In the year 2003, what is the difference between the Emissions(kt) of Qatar and Emissions(kt) of Ukraine?
Ensure brevity in your answer.  -3.66e+04. In the year 2003, what is the difference between the Emissions(kt) in Qatar and Emissions(kt) in Vietnam?
Make the answer very short. -2.15e+04. In the year 2003, what is the difference between the Emissions(kt) in Ukraine and Emissions(kt) in Vietnam?
Keep it short and to the point. 1.52e+04. In the year 2004, what is the difference between the Emissions(kt) in Iceland and Emissions(kt) in Qatar?
Provide a short and direct response. -8463.44. In the year 2004, what is the difference between the Emissions(kt) of Iceland and Emissions(kt) of Ukraine?
Give a very brief answer. -4.49e+04. In the year 2004, what is the difference between the Emissions(kt) in Iceland and Emissions(kt) in Vietnam?
Offer a terse response. -3.21e+04. In the year 2004, what is the difference between the Emissions(kt) in Qatar and Emissions(kt) in Ukraine?
Keep it short and to the point. -3.64e+04. In the year 2004, what is the difference between the Emissions(kt) of Qatar and Emissions(kt) of Vietnam?
Make the answer very short. -2.37e+04. In the year 2004, what is the difference between the Emissions(kt) in Ukraine and Emissions(kt) in Vietnam?
Your response must be concise. 1.28e+04. In the year 2005, what is the difference between the Emissions(kt) of Iceland and Emissions(kt) of Qatar?
Provide a succinct answer. -1.00e+04. In the year 2005, what is the difference between the Emissions(kt) in Iceland and Emissions(kt) in Ukraine?
Keep it short and to the point. -3.54e+04. In the year 2005, what is the difference between the Emissions(kt) of Iceland and Emissions(kt) of Vietnam?
Provide a short and direct response. -3.21e+04. In the year 2005, what is the difference between the Emissions(kt) in Qatar and Emissions(kt) in Ukraine?
Provide a succinct answer. -2.54e+04. In the year 2005, what is the difference between the Emissions(kt) of Qatar and Emissions(kt) of Vietnam?
Your answer should be compact. -2.21e+04. In the year 2005, what is the difference between the Emissions(kt) in Ukraine and Emissions(kt) in Vietnam?
Your answer should be very brief. 3296.63. In the year 2006, what is the difference between the Emissions(kt) of Iceland and Emissions(kt) of Qatar?
Offer a very short reply. -1.01e+04. In the year 2006, what is the difference between the Emissions(kt) of Iceland and Emissions(kt) of Ukraine?
Your answer should be very brief. -3.65e+04. In the year 2006, what is the difference between the Emissions(kt) of Iceland and Emissions(kt) of Vietnam?
Offer a terse response. -3.06e+04. In the year 2006, what is the difference between the Emissions(kt) in Qatar and Emissions(kt) in Ukraine?
Ensure brevity in your answer.  -2.64e+04. In the year 2006, what is the difference between the Emissions(kt) in Qatar and Emissions(kt) in Vietnam?
Offer a terse response. -2.05e+04. In the year 2006, what is the difference between the Emissions(kt) of Ukraine and Emissions(kt) of Vietnam?
Ensure brevity in your answer.  5918.54. In the year 2007, what is the difference between the Emissions(kt) of Iceland and Emissions(kt) of Qatar?
Give a very brief answer. -1.26e+04. In the year 2007, what is the difference between the Emissions(kt) of Iceland and Emissions(kt) of Ukraine?
Keep it short and to the point. -3.96e+04. In the year 2007, what is the difference between the Emissions(kt) in Iceland and Emissions(kt) in Vietnam?
Provide a succinct answer. -3.55e+04. In the year 2007, what is the difference between the Emissions(kt) of Qatar and Emissions(kt) of Ukraine?
Offer a terse response. -2.70e+04. In the year 2007, what is the difference between the Emissions(kt) in Qatar and Emissions(kt) in Vietnam?
Ensure brevity in your answer.  -2.29e+04. In the year 2007, what is the difference between the Emissions(kt) of Ukraine and Emissions(kt) of Vietnam?
Keep it short and to the point. 4022.7. What is the ratio of the Emissions(kt) in Iceland in 2001 to that in 2002?
Offer a terse response. 0.96. What is the ratio of the Emissions(kt) in Qatar in 2001 to that in 2002?
Keep it short and to the point. 2.04. What is the ratio of the Emissions(kt) of Ukraine in 2001 to that in 2002?
Keep it short and to the point. 0.83. What is the ratio of the Emissions(kt) of Vietnam in 2001 to that in 2002?
Offer a very short reply. 0.89. What is the ratio of the Emissions(kt) in Iceland in 2001 to that in 2003?
Give a very brief answer. 0.95. What is the ratio of the Emissions(kt) in Qatar in 2001 to that in 2003?
Provide a short and direct response. 0.56. What is the ratio of the Emissions(kt) in Ukraine in 2001 to that in 2003?
Provide a short and direct response. 0.77. What is the ratio of the Emissions(kt) in Vietnam in 2001 to that in 2003?
Keep it short and to the point. 0.87. What is the ratio of the Emissions(kt) of Iceland in 2001 to that in 2004?
Your response must be concise. 0.94. What is the ratio of the Emissions(kt) of Qatar in 2001 to that in 2004?
Your answer should be compact. 0.44. What is the ratio of the Emissions(kt) of Ukraine in 2001 to that in 2004?
Give a very brief answer. 0.74. What is the ratio of the Emissions(kt) in Vietnam in 2001 to that in 2004?
Your answer should be very brief. 0.75. What is the ratio of the Emissions(kt) in Iceland in 2001 to that in 2005?
Make the answer very short. 0.96. What is the ratio of the Emissions(kt) of Qatar in 2001 to that in 2005?
Make the answer very short. 0.38. What is the ratio of the Emissions(kt) of Ukraine in 2001 to that in 2005?
Your answer should be very brief. 0.92. What is the ratio of the Emissions(kt) of Vietnam in 2001 to that in 2005?
Provide a short and direct response. 0.76. What is the ratio of the Emissions(kt) of Iceland in 2001 to that in 2006?
Your answer should be compact. 0.9. What is the ratio of the Emissions(kt) of Qatar in 2001 to that in 2006?
Your response must be concise. 0.38. What is the ratio of the Emissions(kt) in Ukraine in 2001 to that in 2006?
Your answer should be compact. 0.9. What is the ratio of the Emissions(kt) of Vietnam in 2001 to that in 2006?
Provide a succinct answer. 0.79. What is the ratio of the Emissions(kt) in Iceland in 2001 to that in 2007?
Your response must be concise. 0.92. What is the ratio of the Emissions(kt) of Qatar in 2001 to that in 2007?
Provide a short and direct response. 0.31. What is the ratio of the Emissions(kt) in Ukraine in 2001 to that in 2007?
Give a very brief answer. 0.83. What is the ratio of the Emissions(kt) of Vietnam in 2001 to that in 2007?
Make the answer very short. 0.68. What is the ratio of the Emissions(kt) of Qatar in 2002 to that in 2003?
Your response must be concise. 0.28. What is the ratio of the Emissions(kt) of Ukraine in 2002 to that in 2003?
Offer a terse response. 0.92. What is the ratio of the Emissions(kt) of Vietnam in 2002 to that in 2003?
Your response must be concise. 0.97. What is the ratio of the Emissions(kt) in Iceland in 2002 to that in 2004?
Provide a short and direct response. 0.98. What is the ratio of the Emissions(kt) in Qatar in 2002 to that in 2004?
Make the answer very short. 0.22. What is the ratio of the Emissions(kt) in Ukraine in 2002 to that in 2004?
Make the answer very short. 0.88. What is the ratio of the Emissions(kt) in Vietnam in 2002 to that in 2004?
Make the answer very short. 0.84. What is the ratio of the Emissions(kt) of Iceland in 2002 to that in 2005?
Your response must be concise. 1. What is the ratio of the Emissions(kt) of Qatar in 2002 to that in 2005?
Provide a succinct answer. 0.19. What is the ratio of the Emissions(kt) of Ukraine in 2002 to that in 2005?
Provide a short and direct response. 1.11. What is the ratio of the Emissions(kt) of Vietnam in 2002 to that in 2005?
Offer a very short reply. 0.85. What is the ratio of the Emissions(kt) of Iceland in 2002 to that in 2006?
Your response must be concise. 0.94. What is the ratio of the Emissions(kt) in Qatar in 2002 to that in 2006?
Offer a terse response. 0.19. What is the ratio of the Emissions(kt) in Ukraine in 2002 to that in 2006?
Your response must be concise. 1.07. What is the ratio of the Emissions(kt) of Vietnam in 2002 to that in 2006?
Give a very brief answer. 0.88. What is the ratio of the Emissions(kt) of Iceland in 2002 to that in 2007?
Offer a terse response. 0.96. What is the ratio of the Emissions(kt) of Qatar in 2002 to that in 2007?
Keep it short and to the point. 0.15. What is the ratio of the Emissions(kt) of Ukraine in 2002 to that in 2007?
Provide a succinct answer. 0.99. What is the ratio of the Emissions(kt) in Vietnam in 2002 to that in 2007?
Give a very brief answer. 0.77. What is the ratio of the Emissions(kt) in Iceland in 2003 to that in 2004?
Provide a short and direct response. 0.99. What is the ratio of the Emissions(kt) in Qatar in 2003 to that in 2004?
Your answer should be very brief. 0.79. What is the ratio of the Emissions(kt) of Ukraine in 2003 to that in 2004?
Provide a succinct answer. 0.96. What is the ratio of the Emissions(kt) of Vietnam in 2003 to that in 2004?
Make the answer very short. 0.87. What is the ratio of the Emissions(kt) of Iceland in 2003 to that in 2005?
Your response must be concise. 1.01. What is the ratio of the Emissions(kt) of Qatar in 2003 to that in 2005?
Ensure brevity in your answer.  0.68. What is the ratio of the Emissions(kt) in Ukraine in 2003 to that in 2005?
Provide a short and direct response. 1.2. What is the ratio of the Emissions(kt) of Vietnam in 2003 to that in 2005?
Your answer should be compact. 0.87. What is the ratio of the Emissions(kt) in Iceland in 2003 to that in 2006?
Ensure brevity in your answer.  0.95. What is the ratio of the Emissions(kt) in Qatar in 2003 to that in 2006?
Give a very brief answer. 0.68. What is the ratio of the Emissions(kt) in Ukraine in 2003 to that in 2006?
Provide a short and direct response. 1.17. What is the ratio of the Emissions(kt) of Vietnam in 2003 to that in 2006?
Your response must be concise. 0.91. What is the ratio of the Emissions(kt) of Iceland in 2003 to that in 2007?
Your response must be concise. 0.97. What is the ratio of the Emissions(kt) of Qatar in 2003 to that in 2007?
Your response must be concise. 0.56. What is the ratio of the Emissions(kt) of Ukraine in 2003 to that in 2007?
Offer a very short reply. 1.08. What is the ratio of the Emissions(kt) of Vietnam in 2003 to that in 2007?
Your answer should be very brief. 0.79. What is the ratio of the Emissions(kt) in Iceland in 2004 to that in 2005?
Give a very brief answer. 1.02. What is the ratio of the Emissions(kt) in Qatar in 2004 to that in 2005?
Make the answer very short. 0.87. What is the ratio of the Emissions(kt) in Ukraine in 2004 to that in 2005?
Offer a very short reply. 1.26. What is the ratio of the Emissions(kt) of Iceland in 2004 to that in 2006?
Your response must be concise. 0.96. What is the ratio of the Emissions(kt) of Qatar in 2004 to that in 2006?
Provide a short and direct response. 0.86. What is the ratio of the Emissions(kt) of Ukraine in 2004 to that in 2006?
Ensure brevity in your answer.  1.22. What is the ratio of the Emissions(kt) in Vietnam in 2004 to that in 2006?
Your answer should be very brief. 1.05. What is the ratio of the Emissions(kt) of Iceland in 2004 to that in 2007?
Ensure brevity in your answer.  0.97. What is the ratio of the Emissions(kt) of Qatar in 2004 to that in 2007?
Your answer should be compact. 0.71. What is the ratio of the Emissions(kt) of Ukraine in 2004 to that in 2007?
Your answer should be very brief. 1.13. What is the ratio of the Emissions(kt) of Vietnam in 2004 to that in 2007?
Give a very brief answer. 0.91. What is the ratio of the Emissions(kt) of Iceland in 2005 to that in 2006?
Keep it short and to the point. 0.94. What is the ratio of the Emissions(kt) in Ukraine in 2005 to that in 2006?
Provide a succinct answer. 0.97. What is the ratio of the Emissions(kt) of Vietnam in 2005 to that in 2006?
Keep it short and to the point. 1.04. What is the ratio of the Emissions(kt) in Iceland in 2005 to that in 2007?
Provide a succinct answer. 0.96. What is the ratio of the Emissions(kt) in Qatar in 2005 to that in 2007?
Keep it short and to the point. 0.82. What is the ratio of the Emissions(kt) of Ukraine in 2005 to that in 2007?
Ensure brevity in your answer.  0.9. What is the ratio of the Emissions(kt) of Vietnam in 2005 to that in 2007?
Provide a succinct answer. 0.91. What is the ratio of the Emissions(kt) in Iceland in 2006 to that in 2007?
Provide a succinct answer. 1.02. What is the ratio of the Emissions(kt) of Qatar in 2006 to that in 2007?
Your response must be concise. 0.83. What is the ratio of the Emissions(kt) of Ukraine in 2006 to that in 2007?
Offer a terse response. 0.93. What is the ratio of the Emissions(kt) in Vietnam in 2006 to that in 2007?
Give a very brief answer. 0.87. What is the difference between the highest and the second highest Emissions(kt) in Iceland?
Keep it short and to the point. 29.34. What is the difference between the highest and the second highest Emissions(kt) of Qatar?
Your answer should be compact. 2515.56. What is the difference between the highest and the second highest Emissions(kt) of Ukraine?
Offer a very short reply. 1976.51. What is the difference between the highest and the second highest Emissions(kt) of Vietnam?
Ensure brevity in your answer.  3468.98. What is the difference between the highest and the lowest Emissions(kt) of Iceland?
Provide a succinct answer. 183.35. What is the difference between the highest and the lowest Emissions(kt) of Qatar?
Your response must be concise. 1.22e+04. What is the difference between the highest and the lowest Emissions(kt) in Ukraine?
Your response must be concise. 1.24e+04. What is the difference between the highest and the lowest Emissions(kt) of Vietnam?
Give a very brief answer. 1.18e+04. 